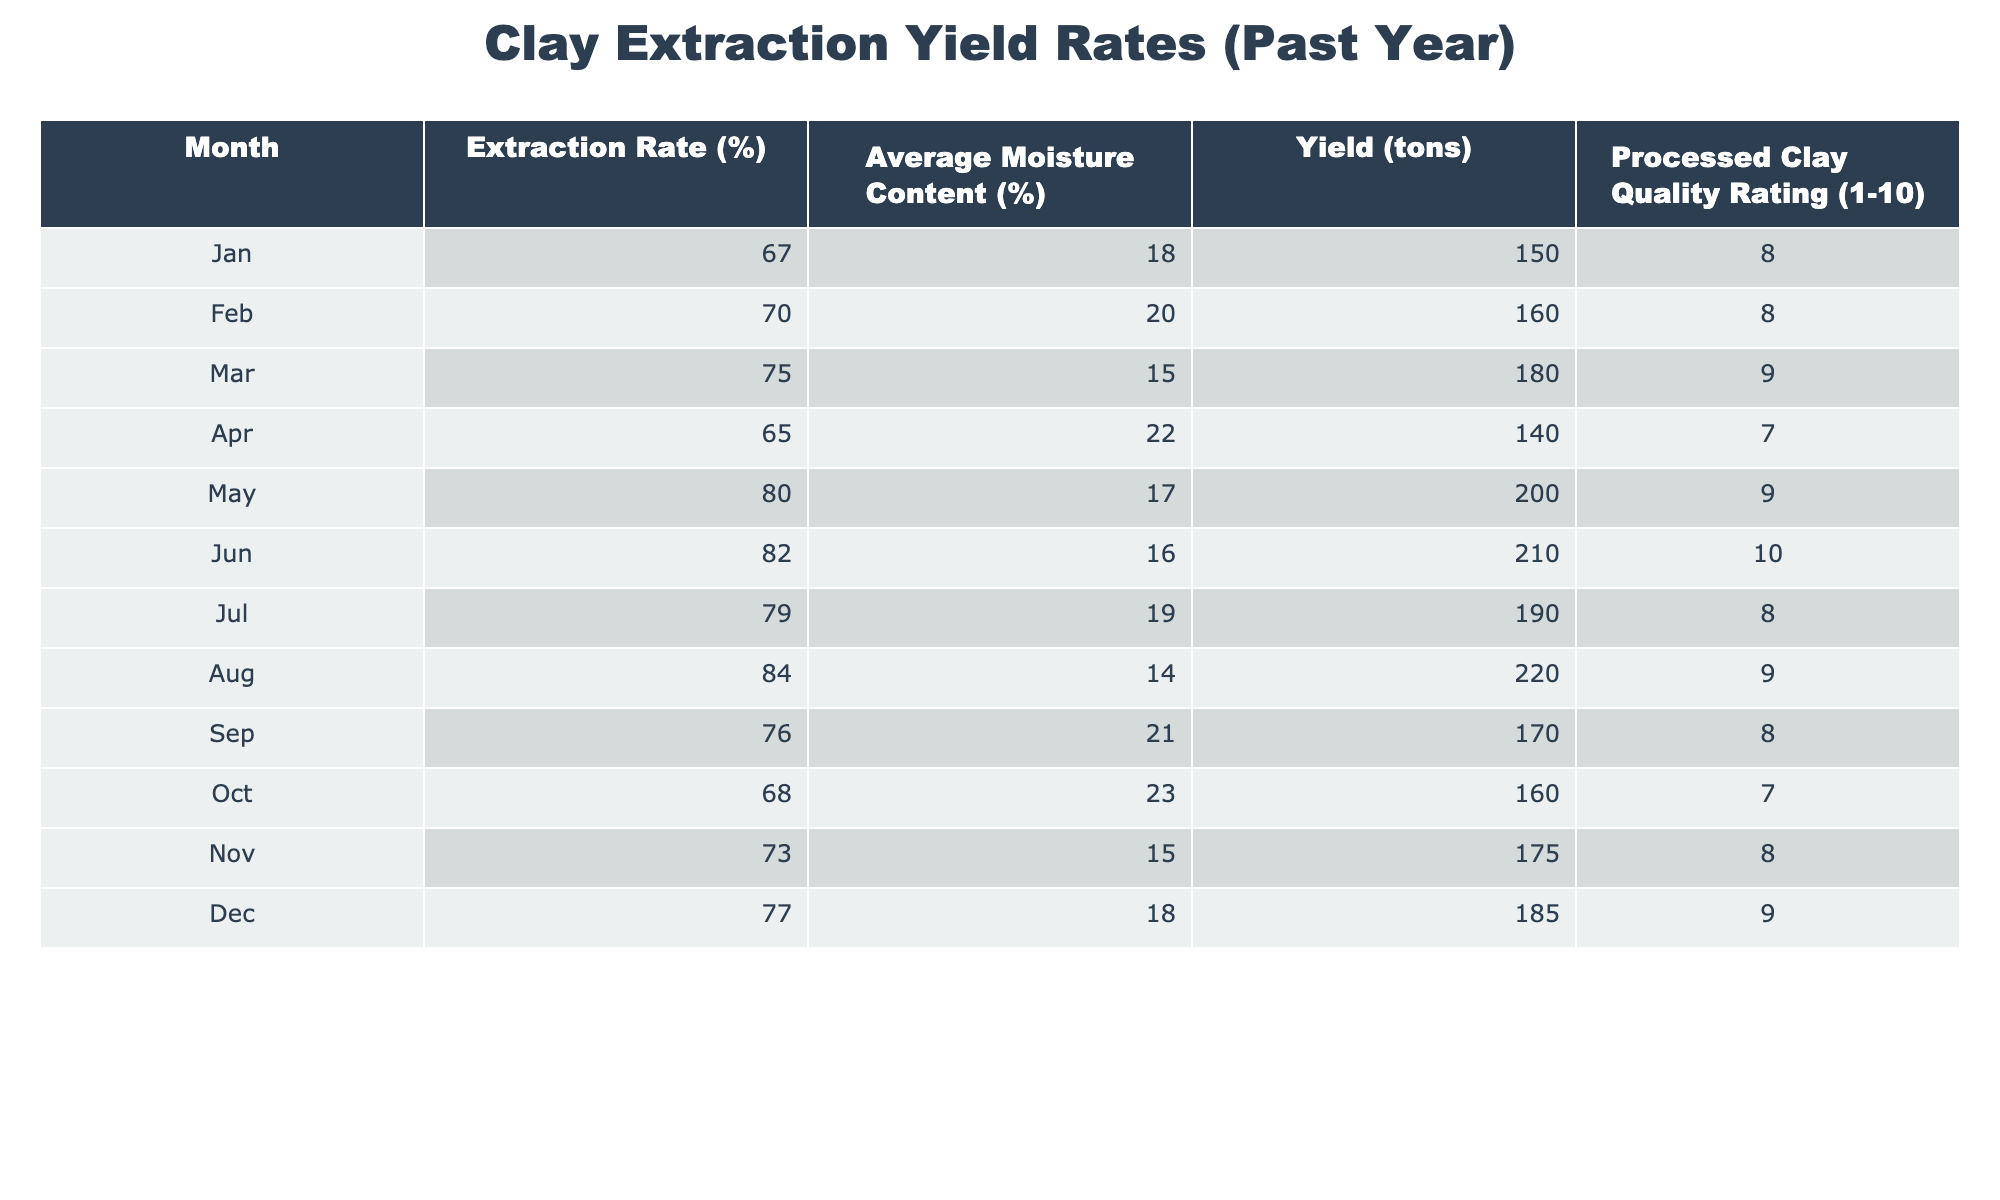What was the extraction rate in July? According to the table, the extraction rate for July is directly listed as 79%.
Answer: 79% What month had the highest yield in tons? The table shows that August had the highest yield at 220 tons.
Answer: August What is the average moisture content across all months? To calculate the average moisture content, add the moisture percentages from all months: (18 + 20 + 15 + 22 + 17 + 16 + 19 + 14 + 21 + 23 + 15 + 18) =  18.5. Then, divide by the number of months (12), giving an average of 18.5%.
Answer: 18.5% Is the processed clay quality rating in June higher than in May? June's quality rating is 10, while May's is 9. Thus, June has a higher rating.
Answer: Yes Which month had a yield rate lower than 70%? By examining the table, only January (67%) and April (65%) had yield rates lower than 70%.
Answer: January and April If we consider only the months with a clay quality rating of 9 or higher, what was the average extraction rate? The months with a rating of 9 or higher are March, May, June, August, November, and December. Their extraction rates are 75%, 80%, 82%, 84%, 73%, and 77%. Adding these gives 471%, and dividing by the six months gives an average extraction rate of 78.5%.
Answer: 78.5% In which months was the average moisture content above 20%? The months with average moisture content above 20% are February (20%), April (22%), and October (23%).
Answer: February, April, October What is the range of yields (in tons) throughout the year? The minimum yield is 140 tons (April) and the maximum is 220 tons (August). The range is calculated by subtracting the minimum from the maximum: 220 - 140 = 80 tons.
Answer: 80 tons Did any month have both an extraction rate above 80% and a quality rating of 10? Yes, June had an extraction rate of 82% and a quality rating of 10, fulfilling both criteria.
Answer: Yes 